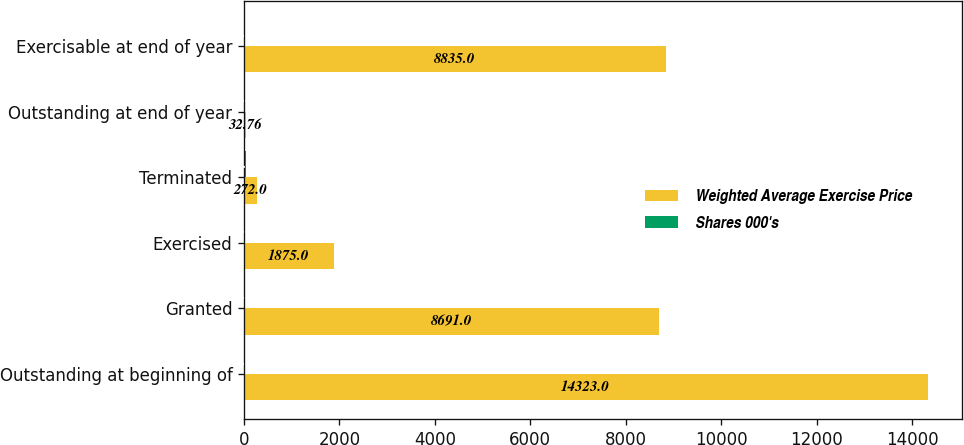Convert chart. <chart><loc_0><loc_0><loc_500><loc_500><stacked_bar_chart><ecel><fcel>Outstanding at beginning of<fcel>Granted<fcel>Exercised<fcel>Terminated<fcel>Outstanding at end of year<fcel>Exercisable at end of year<nl><fcel>Weighted Average Exercise Price<fcel>14323<fcel>8691<fcel>1875<fcel>272<fcel>32.76<fcel>8835<nl><fcel>Shares 000's<fcel>27.18<fcel>26.11<fcel>19.33<fcel>32.76<fcel>27.37<fcel>27.01<nl></chart> 